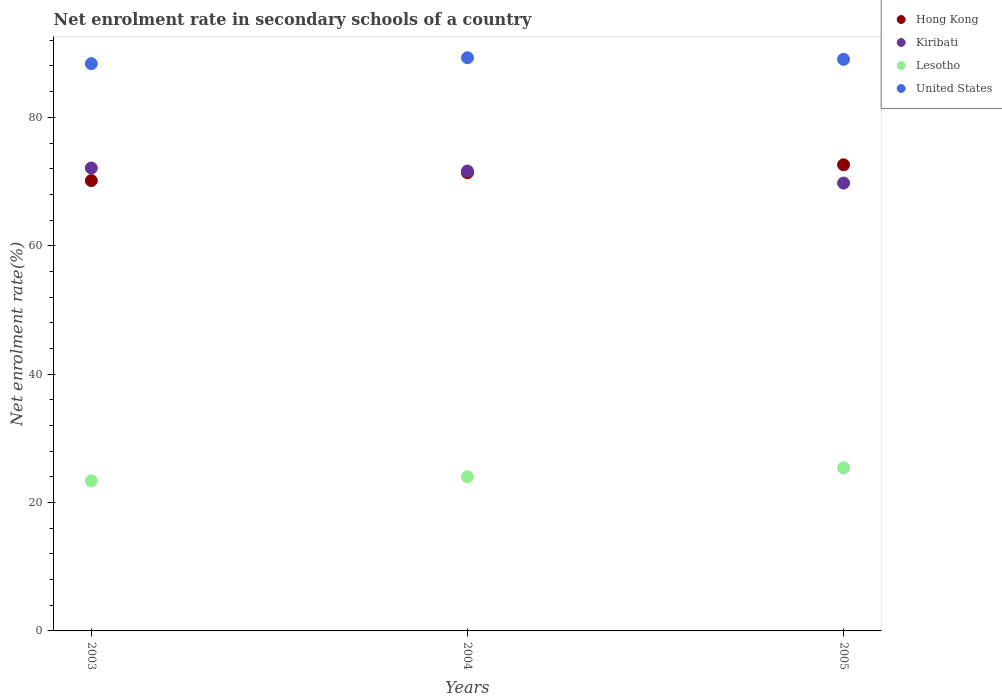How many different coloured dotlines are there?
Ensure brevity in your answer.  4. What is the net enrolment rate in secondary schools in Hong Kong in 2005?
Ensure brevity in your answer.  72.61. Across all years, what is the maximum net enrolment rate in secondary schools in Kiribati?
Your response must be concise. 72.11. Across all years, what is the minimum net enrolment rate in secondary schools in Kiribati?
Your response must be concise. 69.76. In which year was the net enrolment rate in secondary schools in Hong Kong maximum?
Your answer should be compact. 2005. In which year was the net enrolment rate in secondary schools in United States minimum?
Keep it short and to the point. 2003. What is the total net enrolment rate in secondary schools in Hong Kong in the graph?
Your answer should be very brief. 214.13. What is the difference between the net enrolment rate in secondary schools in Kiribati in 2003 and that in 2005?
Your answer should be very brief. 2.35. What is the difference between the net enrolment rate in secondary schools in Lesotho in 2004 and the net enrolment rate in secondary schools in Hong Kong in 2005?
Give a very brief answer. -48.6. What is the average net enrolment rate in secondary schools in Lesotho per year?
Provide a succinct answer. 24.26. In the year 2005, what is the difference between the net enrolment rate in secondary schools in Kiribati and net enrolment rate in secondary schools in United States?
Your answer should be very brief. -19.28. What is the ratio of the net enrolment rate in secondary schools in United States in 2003 to that in 2004?
Offer a terse response. 0.99. What is the difference between the highest and the second highest net enrolment rate in secondary schools in United States?
Ensure brevity in your answer.  0.24. What is the difference between the highest and the lowest net enrolment rate in secondary schools in Hong Kong?
Your response must be concise. 2.46. Is the sum of the net enrolment rate in secondary schools in United States in 2004 and 2005 greater than the maximum net enrolment rate in secondary schools in Lesotho across all years?
Keep it short and to the point. Yes. Is it the case that in every year, the sum of the net enrolment rate in secondary schools in Lesotho and net enrolment rate in secondary schools in Kiribati  is greater than the net enrolment rate in secondary schools in United States?
Your answer should be very brief. Yes. Does the net enrolment rate in secondary schools in Lesotho monotonically increase over the years?
Your answer should be very brief. Yes. Is the net enrolment rate in secondary schools in Hong Kong strictly greater than the net enrolment rate in secondary schools in Kiribati over the years?
Offer a very short reply. No. Is the net enrolment rate in secondary schools in United States strictly less than the net enrolment rate in secondary schools in Lesotho over the years?
Keep it short and to the point. No. How many dotlines are there?
Give a very brief answer. 4. How many years are there in the graph?
Offer a terse response. 3. Does the graph contain any zero values?
Your response must be concise. No. Where does the legend appear in the graph?
Your response must be concise. Top right. What is the title of the graph?
Offer a very short reply. Net enrolment rate in secondary schools of a country. What is the label or title of the Y-axis?
Ensure brevity in your answer.  Net enrolment rate(%). What is the Net enrolment rate(%) in Hong Kong in 2003?
Offer a very short reply. 70.15. What is the Net enrolment rate(%) of Kiribati in 2003?
Offer a terse response. 72.11. What is the Net enrolment rate(%) in Lesotho in 2003?
Make the answer very short. 23.38. What is the Net enrolment rate(%) of United States in 2003?
Provide a succinct answer. 88.36. What is the Net enrolment rate(%) of Hong Kong in 2004?
Your answer should be compact. 71.38. What is the Net enrolment rate(%) of Kiribati in 2004?
Provide a short and direct response. 71.64. What is the Net enrolment rate(%) in Lesotho in 2004?
Offer a very short reply. 24.01. What is the Net enrolment rate(%) in United States in 2004?
Make the answer very short. 89.29. What is the Net enrolment rate(%) in Hong Kong in 2005?
Offer a terse response. 72.61. What is the Net enrolment rate(%) of Kiribati in 2005?
Your response must be concise. 69.76. What is the Net enrolment rate(%) in Lesotho in 2005?
Make the answer very short. 25.4. What is the Net enrolment rate(%) of United States in 2005?
Ensure brevity in your answer.  89.04. Across all years, what is the maximum Net enrolment rate(%) in Hong Kong?
Provide a succinct answer. 72.61. Across all years, what is the maximum Net enrolment rate(%) in Kiribati?
Provide a succinct answer. 72.11. Across all years, what is the maximum Net enrolment rate(%) of Lesotho?
Ensure brevity in your answer.  25.4. Across all years, what is the maximum Net enrolment rate(%) in United States?
Provide a short and direct response. 89.29. Across all years, what is the minimum Net enrolment rate(%) of Hong Kong?
Provide a short and direct response. 70.15. Across all years, what is the minimum Net enrolment rate(%) of Kiribati?
Your answer should be compact. 69.76. Across all years, what is the minimum Net enrolment rate(%) of Lesotho?
Give a very brief answer. 23.38. Across all years, what is the minimum Net enrolment rate(%) in United States?
Your answer should be compact. 88.36. What is the total Net enrolment rate(%) in Hong Kong in the graph?
Your answer should be very brief. 214.13. What is the total Net enrolment rate(%) of Kiribati in the graph?
Give a very brief answer. 213.51. What is the total Net enrolment rate(%) of Lesotho in the graph?
Your response must be concise. 72.79. What is the total Net enrolment rate(%) in United States in the graph?
Your response must be concise. 266.69. What is the difference between the Net enrolment rate(%) in Hong Kong in 2003 and that in 2004?
Offer a terse response. -1.23. What is the difference between the Net enrolment rate(%) of Kiribati in 2003 and that in 2004?
Offer a terse response. 0.47. What is the difference between the Net enrolment rate(%) of Lesotho in 2003 and that in 2004?
Your answer should be compact. -0.63. What is the difference between the Net enrolment rate(%) in United States in 2003 and that in 2004?
Give a very brief answer. -0.92. What is the difference between the Net enrolment rate(%) in Hong Kong in 2003 and that in 2005?
Make the answer very short. -2.46. What is the difference between the Net enrolment rate(%) of Kiribati in 2003 and that in 2005?
Offer a very short reply. 2.35. What is the difference between the Net enrolment rate(%) in Lesotho in 2003 and that in 2005?
Your answer should be very brief. -2.03. What is the difference between the Net enrolment rate(%) of United States in 2003 and that in 2005?
Your answer should be compact. -0.68. What is the difference between the Net enrolment rate(%) in Hong Kong in 2004 and that in 2005?
Provide a short and direct response. -1.23. What is the difference between the Net enrolment rate(%) in Kiribati in 2004 and that in 2005?
Your answer should be compact. 1.88. What is the difference between the Net enrolment rate(%) in Lesotho in 2004 and that in 2005?
Your response must be concise. -1.39. What is the difference between the Net enrolment rate(%) of United States in 2004 and that in 2005?
Provide a succinct answer. 0.24. What is the difference between the Net enrolment rate(%) in Hong Kong in 2003 and the Net enrolment rate(%) in Kiribati in 2004?
Offer a very short reply. -1.49. What is the difference between the Net enrolment rate(%) of Hong Kong in 2003 and the Net enrolment rate(%) of Lesotho in 2004?
Ensure brevity in your answer.  46.14. What is the difference between the Net enrolment rate(%) of Hong Kong in 2003 and the Net enrolment rate(%) of United States in 2004?
Offer a terse response. -19.14. What is the difference between the Net enrolment rate(%) of Kiribati in 2003 and the Net enrolment rate(%) of Lesotho in 2004?
Provide a short and direct response. 48.1. What is the difference between the Net enrolment rate(%) in Kiribati in 2003 and the Net enrolment rate(%) in United States in 2004?
Offer a terse response. -17.18. What is the difference between the Net enrolment rate(%) of Lesotho in 2003 and the Net enrolment rate(%) of United States in 2004?
Give a very brief answer. -65.91. What is the difference between the Net enrolment rate(%) in Hong Kong in 2003 and the Net enrolment rate(%) in Kiribati in 2005?
Provide a short and direct response. 0.38. What is the difference between the Net enrolment rate(%) of Hong Kong in 2003 and the Net enrolment rate(%) of Lesotho in 2005?
Offer a terse response. 44.74. What is the difference between the Net enrolment rate(%) in Hong Kong in 2003 and the Net enrolment rate(%) in United States in 2005?
Offer a very short reply. -18.9. What is the difference between the Net enrolment rate(%) of Kiribati in 2003 and the Net enrolment rate(%) of Lesotho in 2005?
Offer a very short reply. 46.7. What is the difference between the Net enrolment rate(%) in Kiribati in 2003 and the Net enrolment rate(%) in United States in 2005?
Your response must be concise. -16.93. What is the difference between the Net enrolment rate(%) of Lesotho in 2003 and the Net enrolment rate(%) of United States in 2005?
Offer a very short reply. -65.67. What is the difference between the Net enrolment rate(%) in Hong Kong in 2004 and the Net enrolment rate(%) in Kiribati in 2005?
Keep it short and to the point. 1.61. What is the difference between the Net enrolment rate(%) in Hong Kong in 2004 and the Net enrolment rate(%) in Lesotho in 2005?
Provide a short and direct response. 45.97. What is the difference between the Net enrolment rate(%) of Hong Kong in 2004 and the Net enrolment rate(%) of United States in 2005?
Your response must be concise. -17.66. What is the difference between the Net enrolment rate(%) in Kiribati in 2004 and the Net enrolment rate(%) in Lesotho in 2005?
Your answer should be very brief. 46.24. What is the difference between the Net enrolment rate(%) in Kiribati in 2004 and the Net enrolment rate(%) in United States in 2005?
Give a very brief answer. -17.4. What is the difference between the Net enrolment rate(%) of Lesotho in 2004 and the Net enrolment rate(%) of United States in 2005?
Your answer should be very brief. -65.03. What is the average Net enrolment rate(%) in Hong Kong per year?
Offer a terse response. 71.38. What is the average Net enrolment rate(%) of Kiribati per year?
Provide a succinct answer. 71.17. What is the average Net enrolment rate(%) of Lesotho per year?
Your answer should be very brief. 24.26. What is the average Net enrolment rate(%) in United States per year?
Offer a terse response. 88.9. In the year 2003, what is the difference between the Net enrolment rate(%) of Hong Kong and Net enrolment rate(%) of Kiribati?
Provide a short and direct response. -1.96. In the year 2003, what is the difference between the Net enrolment rate(%) in Hong Kong and Net enrolment rate(%) in Lesotho?
Provide a succinct answer. 46.77. In the year 2003, what is the difference between the Net enrolment rate(%) in Hong Kong and Net enrolment rate(%) in United States?
Offer a terse response. -18.22. In the year 2003, what is the difference between the Net enrolment rate(%) in Kiribati and Net enrolment rate(%) in Lesotho?
Your answer should be compact. 48.73. In the year 2003, what is the difference between the Net enrolment rate(%) of Kiribati and Net enrolment rate(%) of United States?
Your answer should be very brief. -16.26. In the year 2003, what is the difference between the Net enrolment rate(%) of Lesotho and Net enrolment rate(%) of United States?
Provide a succinct answer. -64.99. In the year 2004, what is the difference between the Net enrolment rate(%) in Hong Kong and Net enrolment rate(%) in Kiribati?
Your response must be concise. -0.26. In the year 2004, what is the difference between the Net enrolment rate(%) in Hong Kong and Net enrolment rate(%) in Lesotho?
Give a very brief answer. 47.37. In the year 2004, what is the difference between the Net enrolment rate(%) in Hong Kong and Net enrolment rate(%) in United States?
Offer a very short reply. -17.91. In the year 2004, what is the difference between the Net enrolment rate(%) in Kiribati and Net enrolment rate(%) in Lesotho?
Your response must be concise. 47.63. In the year 2004, what is the difference between the Net enrolment rate(%) in Kiribati and Net enrolment rate(%) in United States?
Make the answer very short. -17.65. In the year 2004, what is the difference between the Net enrolment rate(%) in Lesotho and Net enrolment rate(%) in United States?
Ensure brevity in your answer.  -65.28. In the year 2005, what is the difference between the Net enrolment rate(%) in Hong Kong and Net enrolment rate(%) in Kiribati?
Ensure brevity in your answer.  2.84. In the year 2005, what is the difference between the Net enrolment rate(%) of Hong Kong and Net enrolment rate(%) of Lesotho?
Give a very brief answer. 47.2. In the year 2005, what is the difference between the Net enrolment rate(%) of Hong Kong and Net enrolment rate(%) of United States?
Offer a terse response. -16.44. In the year 2005, what is the difference between the Net enrolment rate(%) of Kiribati and Net enrolment rate(%) of Lesotho?
Provide a short and direct response. 44.36. In the year 2005, what is the difference between the Net enrolment rate(%) of Kiribati and Net enrolment rate(%) of United States?
Ensure brevity in your answer.  -19.28. In the year 2005, what is the difference between the Net enrolment rate(%) of Lesotho and Net enrolment rate(%) of United States?
Give a very brief answer. -63.64. What is the ratio of the Net enrolment rate(%) in Hong Kong in 2003 to that in 2004?
Your answer should be very brief. 0.98. What is the ratio of the Net enrolment rate(%) in Kiribati in 2003 to that in 2004?
Your answer should be compact. 1.01. What is the ratio of the Net enrolment rate(%) of Lesotho in 2003 to that in 2004?
Provide a succinct answer. 0.97. What is the ratio of the Net enrolment rate(%) in United States in 2003 to that in 2004?
Your answer should be compact. 0.99. What is the ratio of the Net enrolment rate(%) in Hong Kong in 2003 to that in 2005?
Your answer should be very brief. 0.97. What is the ratio of the Net enrolment rate(%) of Kiribati in 2003 to that in 2005?
Ensure brevity in your answer.  1.03. What is the ratio of the Net enrolment rate(%) in Lesotho in 2003 to that in 2005?
Keep it short and to the point. 0.92. What is the ratio of the Net enrolment rate(%) in Hong Kong in 2004 to that in 2005?
Make the answer very short. 0.98. What is the ratio of the Net enrolment rate(%) of Kiribati in 2004 to that in 2005?
Keep it short and to the point. 1.03. What is the ratio of the Net enrolment rate(%) of Lesotho in 2004 to that in 2005?
Keep it short and to the point. 0.95. What is the ratio of the Net enrolment rate(%) in United States in 2004 to that in 2005?
Offer a terse response. 1. What is the difference between the highest and the second highest Net enrolment rate(%) in Hong Kong?
Offer a terse response. 1.23. What is the difference between the highest and the second highest Net enrolment rate(%) of Kiribati?
Your response must be concise. 0.47. What is the difference between the highest and the second highest Net enrolment rate(%) in Lesotho?
Your answer should be compact. 1.39. What is the difference between the highest and the second highest Net enrolment rate(%) in United States?
Your answer should be very brief. 0.24. What is the difference between the highest and the lowest Net enrolment rate(%) of Hong Kong?
Keep it short and to the point. 2.46. What is the difference between the highest and the lowest Net enrolment rate(%) of Kiribati?
Provide a succinct answer. 2.35. What is the difference between the highest and the lowest Net enrolment rate(%) of Lesotho?
Make the answer very short. 2.03. What is the difference between the highest and the lowest Net enrolment rate(%) in United States?
Your answer should be very brief. 0.92. 